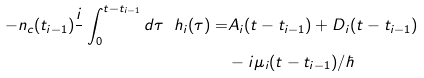Convert formula to latex. <formula><loc_0><loc_0><loc_500><loc_500>- n _ { c } ( t _ { i - 1 } ) \frac { i } { } \int _ { 0 } ^ { t - t _ { i - 1 } } d \tau \ h _ { i } ( \tau ) = & A _ { i } ( t - t _ { i - 1 } ) + D _ { i } ( t - t _ { i - 1 } ) \\ & - i \mu _ { i } ( t - t _ { i - 1 } ) / \hbar</formula> 